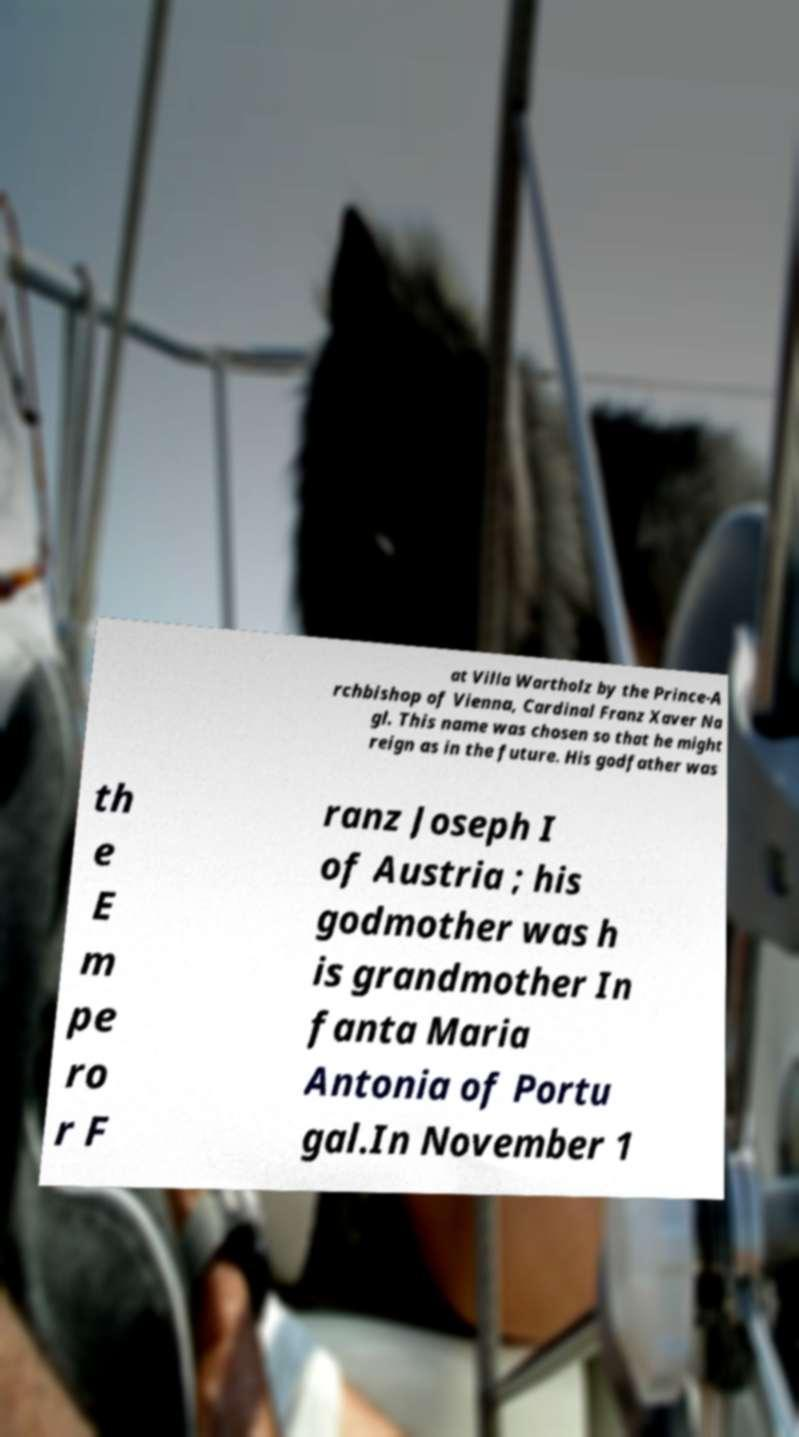Could you assist in decoding the text presented in this image and type it out clearly? at Villa Wartholz by the Prince-A rchbishop of Vienna, Cardinal Franz Xaver Na gl. This name was chosen so that he might reign as in the future. His godfather was th e E m pe ro r F ranz Joseph I of Austria ; his godmother was h is grandmother In fanta Maria Antonia of Portu gal.In November 1 